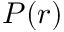Convert formula to latex. <formula><loc_0><loc_0><loc_500><loc_500>P ( r )</formula> 